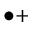<formula> <loc_0><loc_0><loc_500><loc_500>\bullet +</formula> 